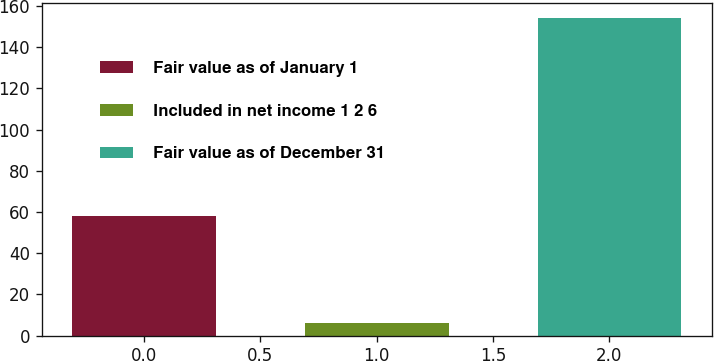<chart> <loc_0><loc_0><loc_500><loc_500><bar_chart><fcel>Fair value as of January 1<fcel>Included in net income 1 2 6<fcel>Fair value as of December 31<nl><fcel>58<fcel>6<fcel>154<nl></chart> 